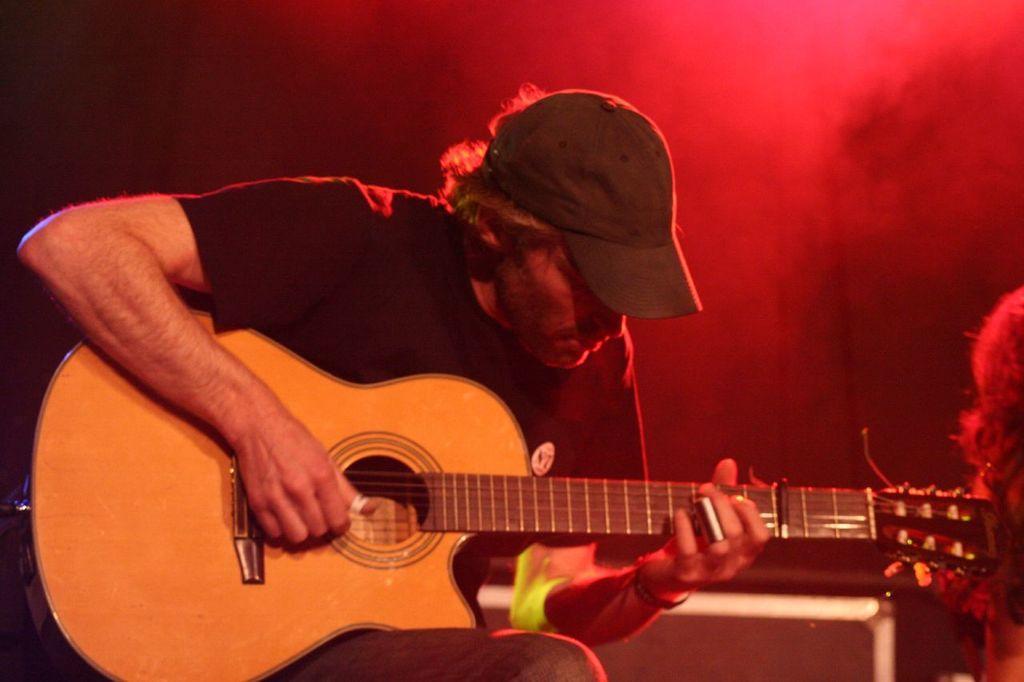Can you describe this image briefly? In the picture there is person sitting and playing guitar there is a red light near to him. 